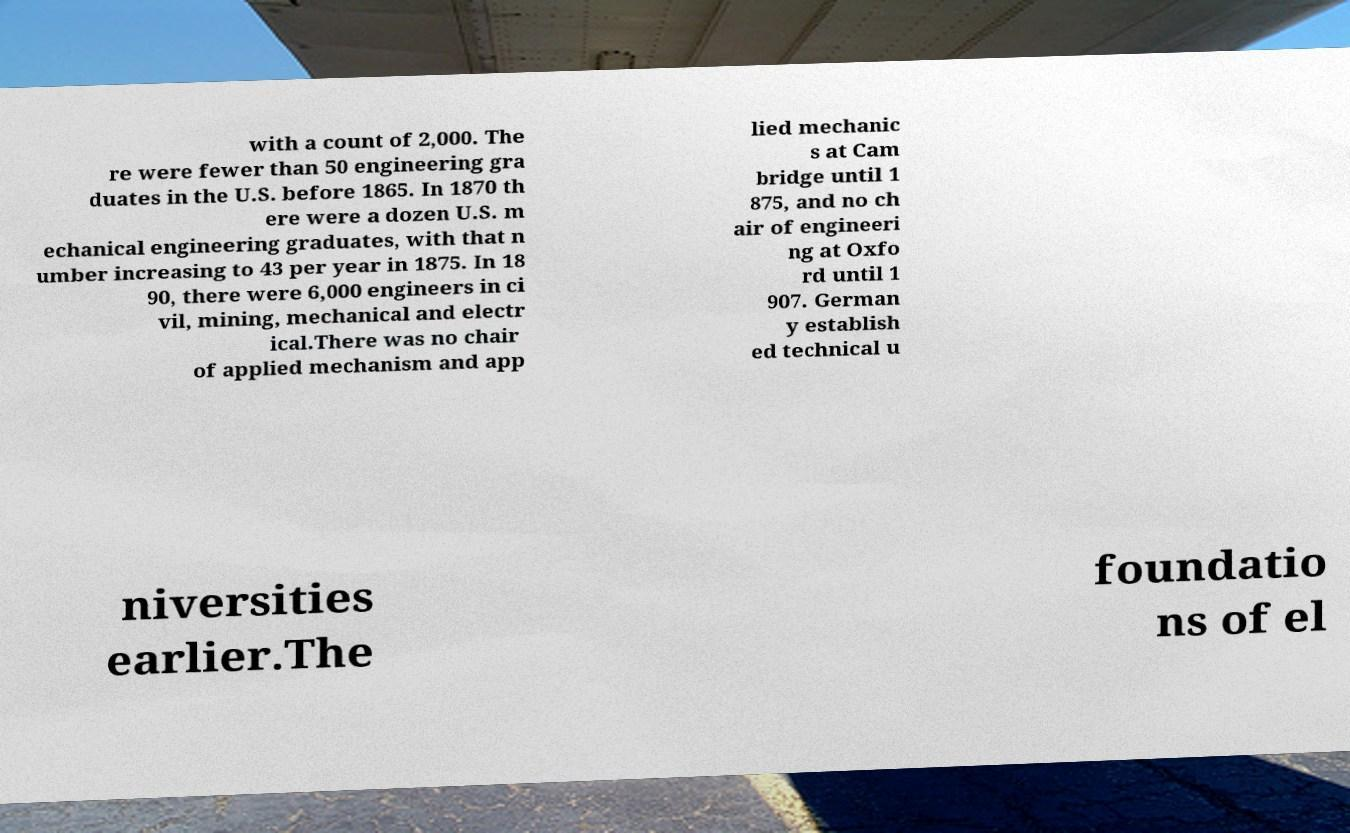Could you extract and type out the text from this image? with a count of 2,000. The re were fewer than 50 engineering gra duates in the U.S. before 1865. In 1870 th ere were a dozen U.S. m echanical engineering graduates, with that n umber increasing to 43 per year in 1875. In 18 90, there were 6,000 engineers in ci vil, mining, mechanical and electr ical.There was no chair of applied mechanism and app lied mechanic s at Cam bridge until 1 875, and no ch air of engineeri ng at Oxfo rd until 1 907. German y establish ed technical u niversities earlier.The foundatio ns of el 